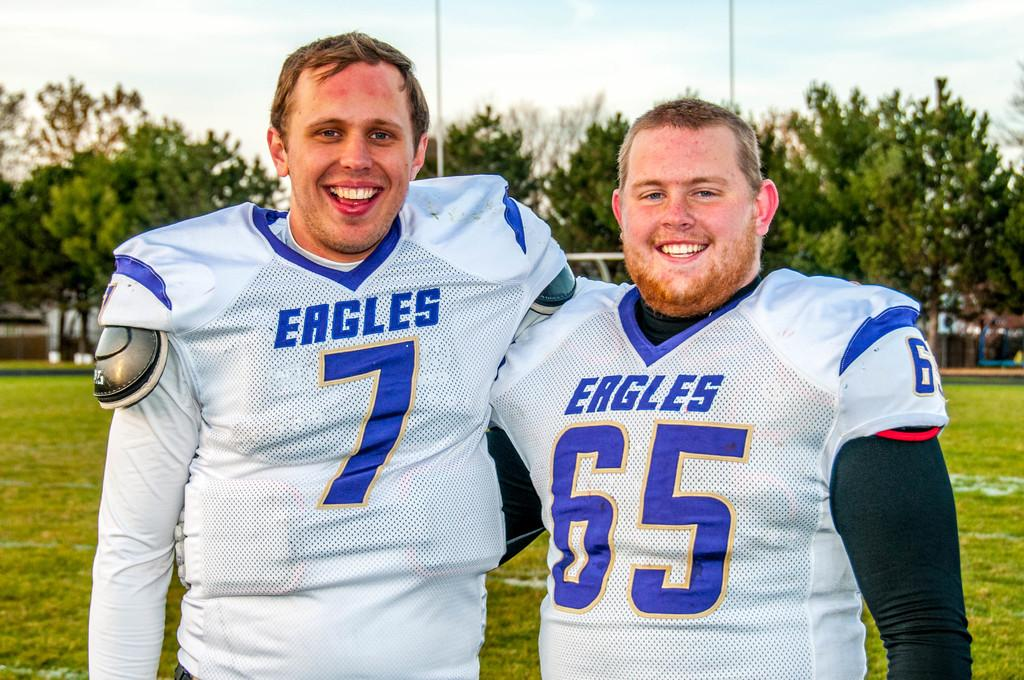<image>
Offer a succinct explanation of the picture presented. Two Eagles football players are smiling for the camera. 